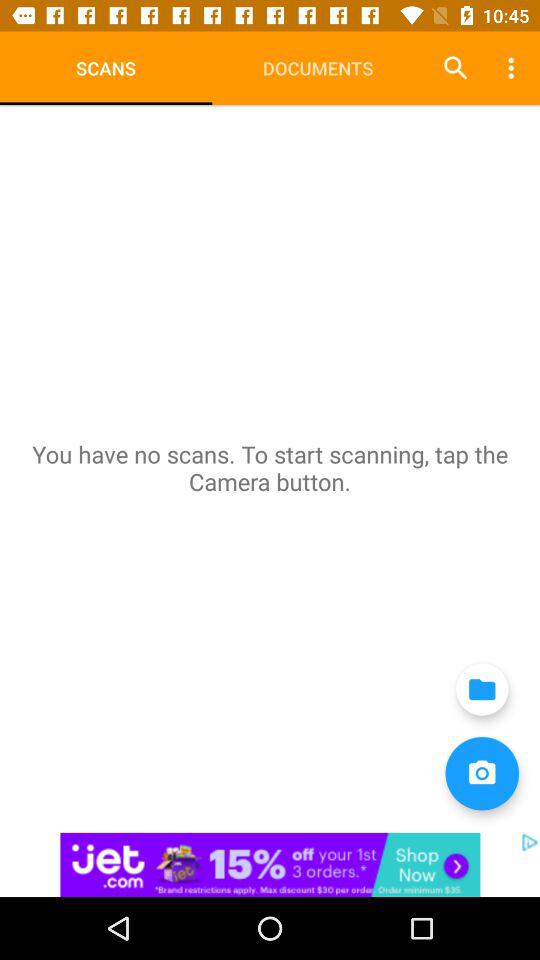Which tab am I using? You are using the "SCANS" tab. 